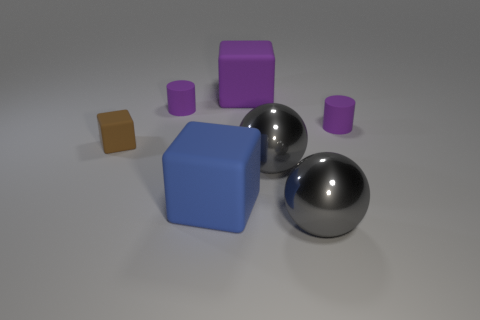Does the big blue thing have the same material as the small purple object to the left of the blue matte thing?
Offer a terse response. Yes. Are there any other things that are the same shape as the large purple matte object?
Keep it short and to the point. Yes. Does the purple cube have the same material as the large blue thing?
Make the answer very short. Yes. Are there any gray things in front of the gray object in front of the blue cube?
Offer a terse response. No. How many matte objects are left of the blue matte cube and to the right of the large blue thing?
Your response must be concise. 0. There is a gray thing in front of the blue matte block; what shape is it?
Offer a very short reply. Sphere. How many rubber objects have the same size as the blue cube?
Your response must be concise. 1. Do the big ball in front of the blue object and the small block have the same color?
Make the answer very short. No. There is a object that is both right of the large purple object and behind the tiny brown block; what is it made of?
Make the answer very short. Rubber. Is the number of gray objects greater than the number of blue rubber cubes?
Provide a short and direct response. Yes. 